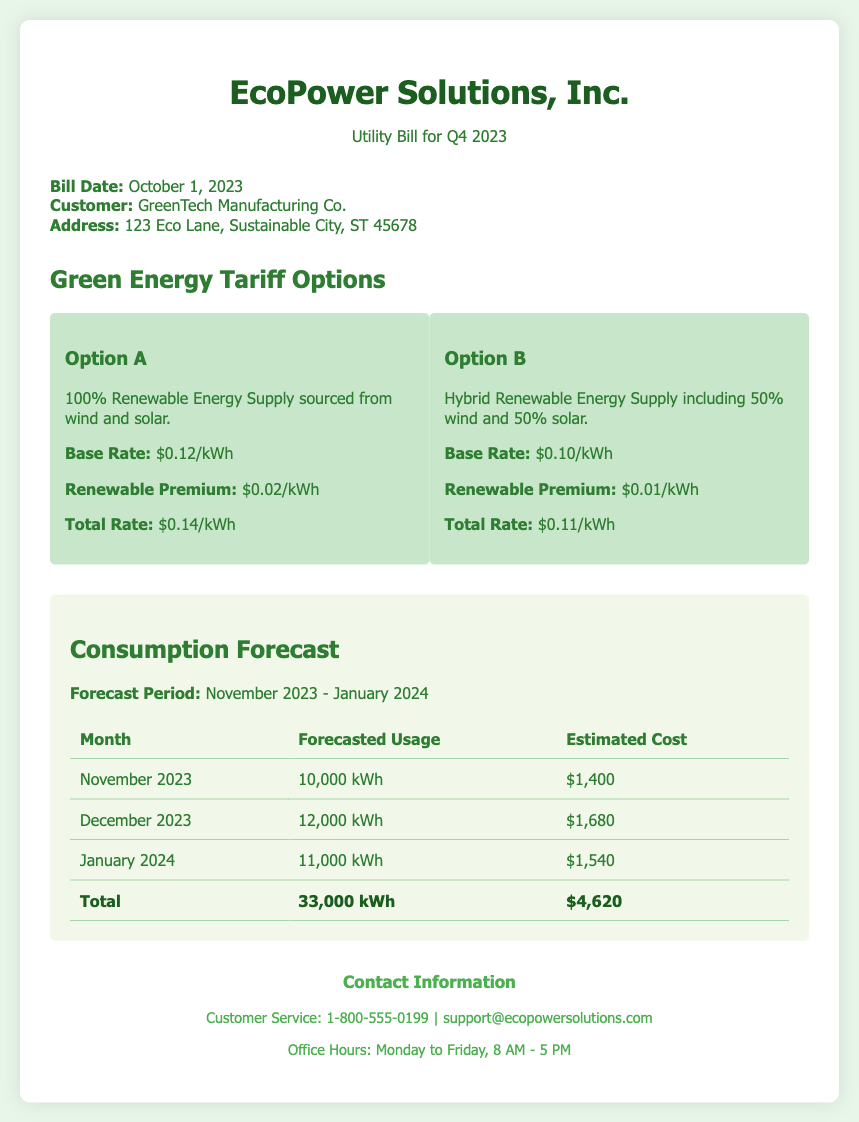What is the bill date? The bill date is specified in the document under the bill info section.
Answer: October 1, 2023 What is the base rate for Option A? The base rate for Option A is mentioned in the green energy tariff options section.
Answer: $0.12/kWh What is the total estimated cost for January 2024? The total estimated cost for January 2024 is provided in the consumption forecast table.
Answer: $1,540 How many kWh is forecasted for December 2023? The forecasted usage for December 2023 is detailed in the forecast section of the document.
Answer: 12,000 kWh Which plan has a total rate of $0.11/kWh? The total rate for each plan is outlined in the green energy tariff options section.
Answer: Option B What is the total forecasted usage for the period? The total forecasted usage is calculated by summing the forecasted usage for all three months in the table.
Answer: 33,000 kWh What is the renewable premium for Option A? The renewable premium is listed under each option in the green energy tariff section.
Answer: $0.02/kWh Which company is the customer on the bill? The customer name is located in the bill info section.
Answer: GreenTech Manufacturing Co 